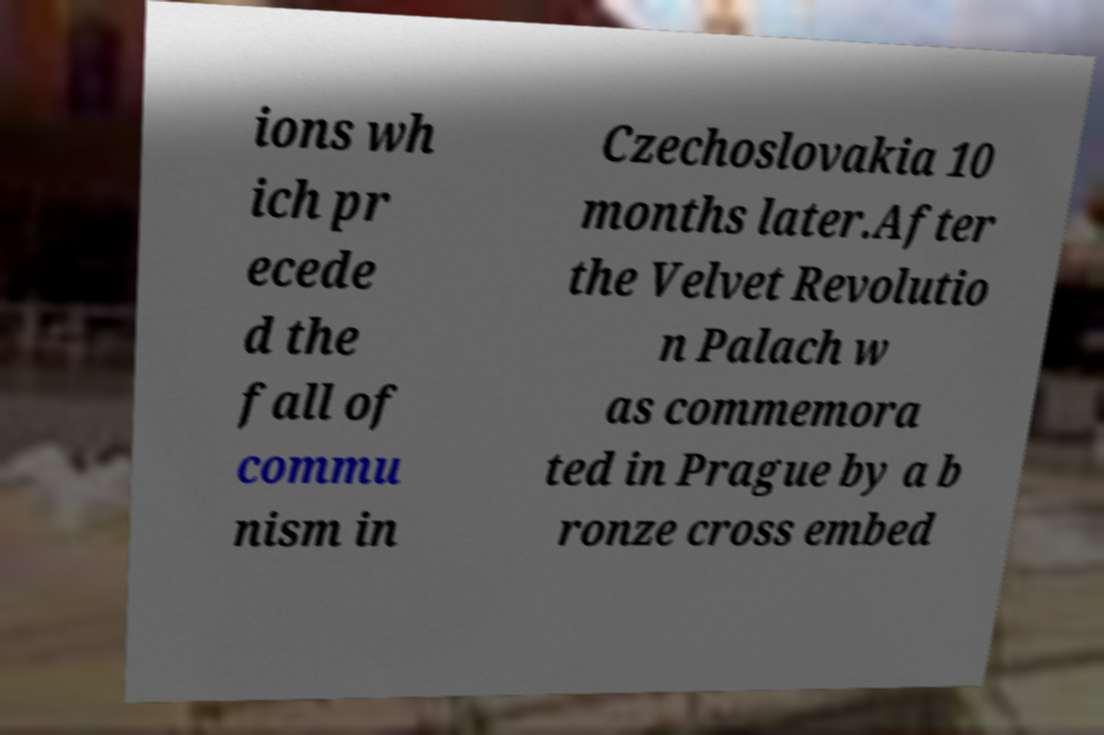Could you assist in decoding the text presented in this image and type it out clearly? ions wh ich pr ecede d the fall of commu nism in Czechoslovakia 10 months later.After the Velvet Revolutio n Palach w as commemora ted in Prague by a b ronze cross embed 